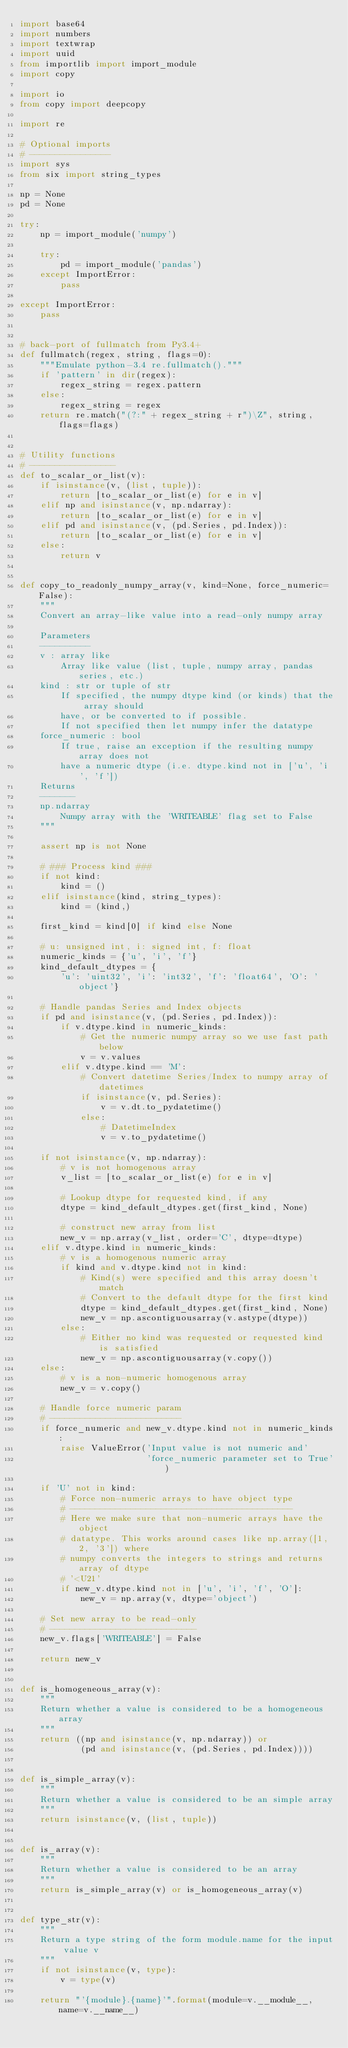Convert code to text. <code><loc_0><loc_0><loc_500><loc_500><_Python_>import base64
import numbers
import textwrap
import uuid
from importlib import import_module
import copy

import io
from copy import deepcopy

import re

# Optional imports
# ----------------
import sys
from six import string_types

np = None
pd = None

try:
    np = import_module('numpy')

    try:
        pd = import_module('pandas')
    except ImportError:
        pass

except ImportError:
    pass


# back-port of fullmatch from Py3.4+
def fullmatch(regex, string, flags=0):
    """Emulate python-3.4 re.fullmatch()."""
    if 'pattern' in dir(regex):
        regex_string = regex.pattern
    else:
        regex_string = regex
    return re.match("(?:" + regex_string + r")\Z", string, flags=flags)


# Utility functions
# -----------------
def to_scalar_or_list(v):
    if isinstance(v, (list, tuple)):
        return [to_scalar_or_list(e) for e in v]
    elif np and isinstance(v, np.ndarray):
        return [to_scalar_or_list(e) for e in v]
    elif pd and isinstance(v, (pd.Series, pd.Index)):
        return [to_scalar_or_list(e) for e in v]
    else:
        return v


def copy_to_readonly_numpy_array(v, kind=None, force_numeric=False):
    """
    Convert an array-like value into a read-only numpy array

    Parameters
    ----------
    v : array like
        Array like value (list, tuple, numpy array, pandas series, etc.)
    kind : str or tuple of str
        If specified, the numpy dtype kind (or kinds) that the array should
        have, or be converted to if possible.
        If not specified then let numpy infer the datatype
    force_numeric : bool
        If true, raise an exception if the resulting numpy array does not
        have a numeric dtype (i.e. dtype.kind not in ['u', 'i', 'f'])
    Returns
    -------
    np.ndarray
        Numpy array with the 'WRITEABLE' flag set to False
    """

    assert np is not None

    # ### Process kind ###
    if not kind:
        kind = ()
    elif isinstance(kind, string_types):
        kind = (kind,)

    first_kind = kind[0] if kind else None

    # u: unsigned int, i: signed int, f: float
    numeric_kinds = {'u', 'i', 'f'}
    kind_default_dtypes = {
        'u': 'uint32', 'i': 'int32', 'f': 'float64', 'O': 'object'}

    # Handle pandas Series and Index objects
    if pd and isinstance(v, (pd.Series, pd.Index)):
        if v.dtype.kind in numeric_kinds:
            # Get the numeric numpy array so we use fast path below
            v = v.values
        elif v.dtype.kind == 'M':
            # Convert datetime Series/Index to numpy array of datetimes
            if isinstance(v, pd.Series):
                v = v.dt.to_pydatetime()
            else:
                # DatetimeIndex
                v = v.to_pydatetime()

    if not isinstance(v, np.ndarray):
        # v is not homogenous array
        v_list = [to_scalar_or_list(e) for e in v]

        # Lookup dtype for requested kind, if any
        dtype = kind_default_dtypes.get(first_kind, None)

        # construct new array from list
        new_v = np.array(v_list, order='C', dtype=dtype)
    elif v.dtype.kind in numeric_kinds:
        # v is a homogenous numeric array
        if kind and v.dtype.kind not in kind:
            # Kind(s) were specified and this array doesn't match
            # Convert to the default dtype for the first kind
            dtype = kind_default_dtypes.get(first_kind, None)
            new_v = np.ascontiguousarray(v.astype(dtype))
        else:
            # Either no kind was requested or requested kind is satisfied
            new_v = np.ascontiguousarray(v.copy())
    else:
        # v is a non-numeric homogenous array
        new_v = v.copy()

    # Handle force numeric param
    # --------------------------
    if force_numeric and new_v.dtype.kind not in numeric_kinds:
        raise ValueError('Input value is not numeric and'
                         'force_numeric parameter set to True')

    if 'U' not in kind:
        # Force non-numeric arrays to have object type
        # --------------------------------------------
        # Here we make sure that non-numeric arrays have the object
        # datatype. This works around cases like np.array([1, 2, '3']) where
        # numpy converts the integers to strings and returns array of dtype
        # '<U21'
        if new_v.dtype.kind not in ['u', 'i', 'f', 'O']:
            new_v = np.array(v, dtype='object')

    # Set new array to be read-only
    # -----------------------------
    new_v.flags['WRITEABLE'] = False

    return new_v


def is_homogeneous_array(v):
    """
    Return whether a value is considered to be a homogeneous array
    """
    return ((np and isinstance(v, np.ndarray)) or
            (pd and isinstance(v, (pd.Series, pd.Index))))


def is_simple_array(v):
    """
    Return whether a value is considered to be an simple array
    """
    return isinstance(v, (list, tuple))


def is_array(v):
    """
    Return whether a value is considered to be an array
    """
    return is_simple_array(v) or is_homogeneous_array(v)


def type_str(v):
    """
    Return a type string of the form module.name for the input value v
    """
    if not isinstance(v, type):
        v = type(v)

    return "'{module}.{name}'".format(module=v.__module__, name=v.__name__)

</code> 